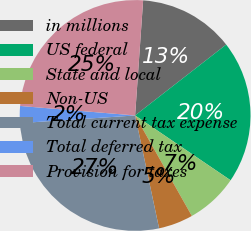Convert chart. <chart><loc_0><loc_0><loc_500><loc_500><pie_chart><fcel>in millions<fcel>US federal<fcel>State and local<fcel>Non-US<fcel>Total current tax expense<fcel>Total deferred tax<fcel>Provision for taxes<nl><fcel>13.37%<fcel>20.02%<fcel>7.33%<fcel>4.85%<fcel>27.28%<fcel>2.37%<fcel>24.8%<nl></chart> 